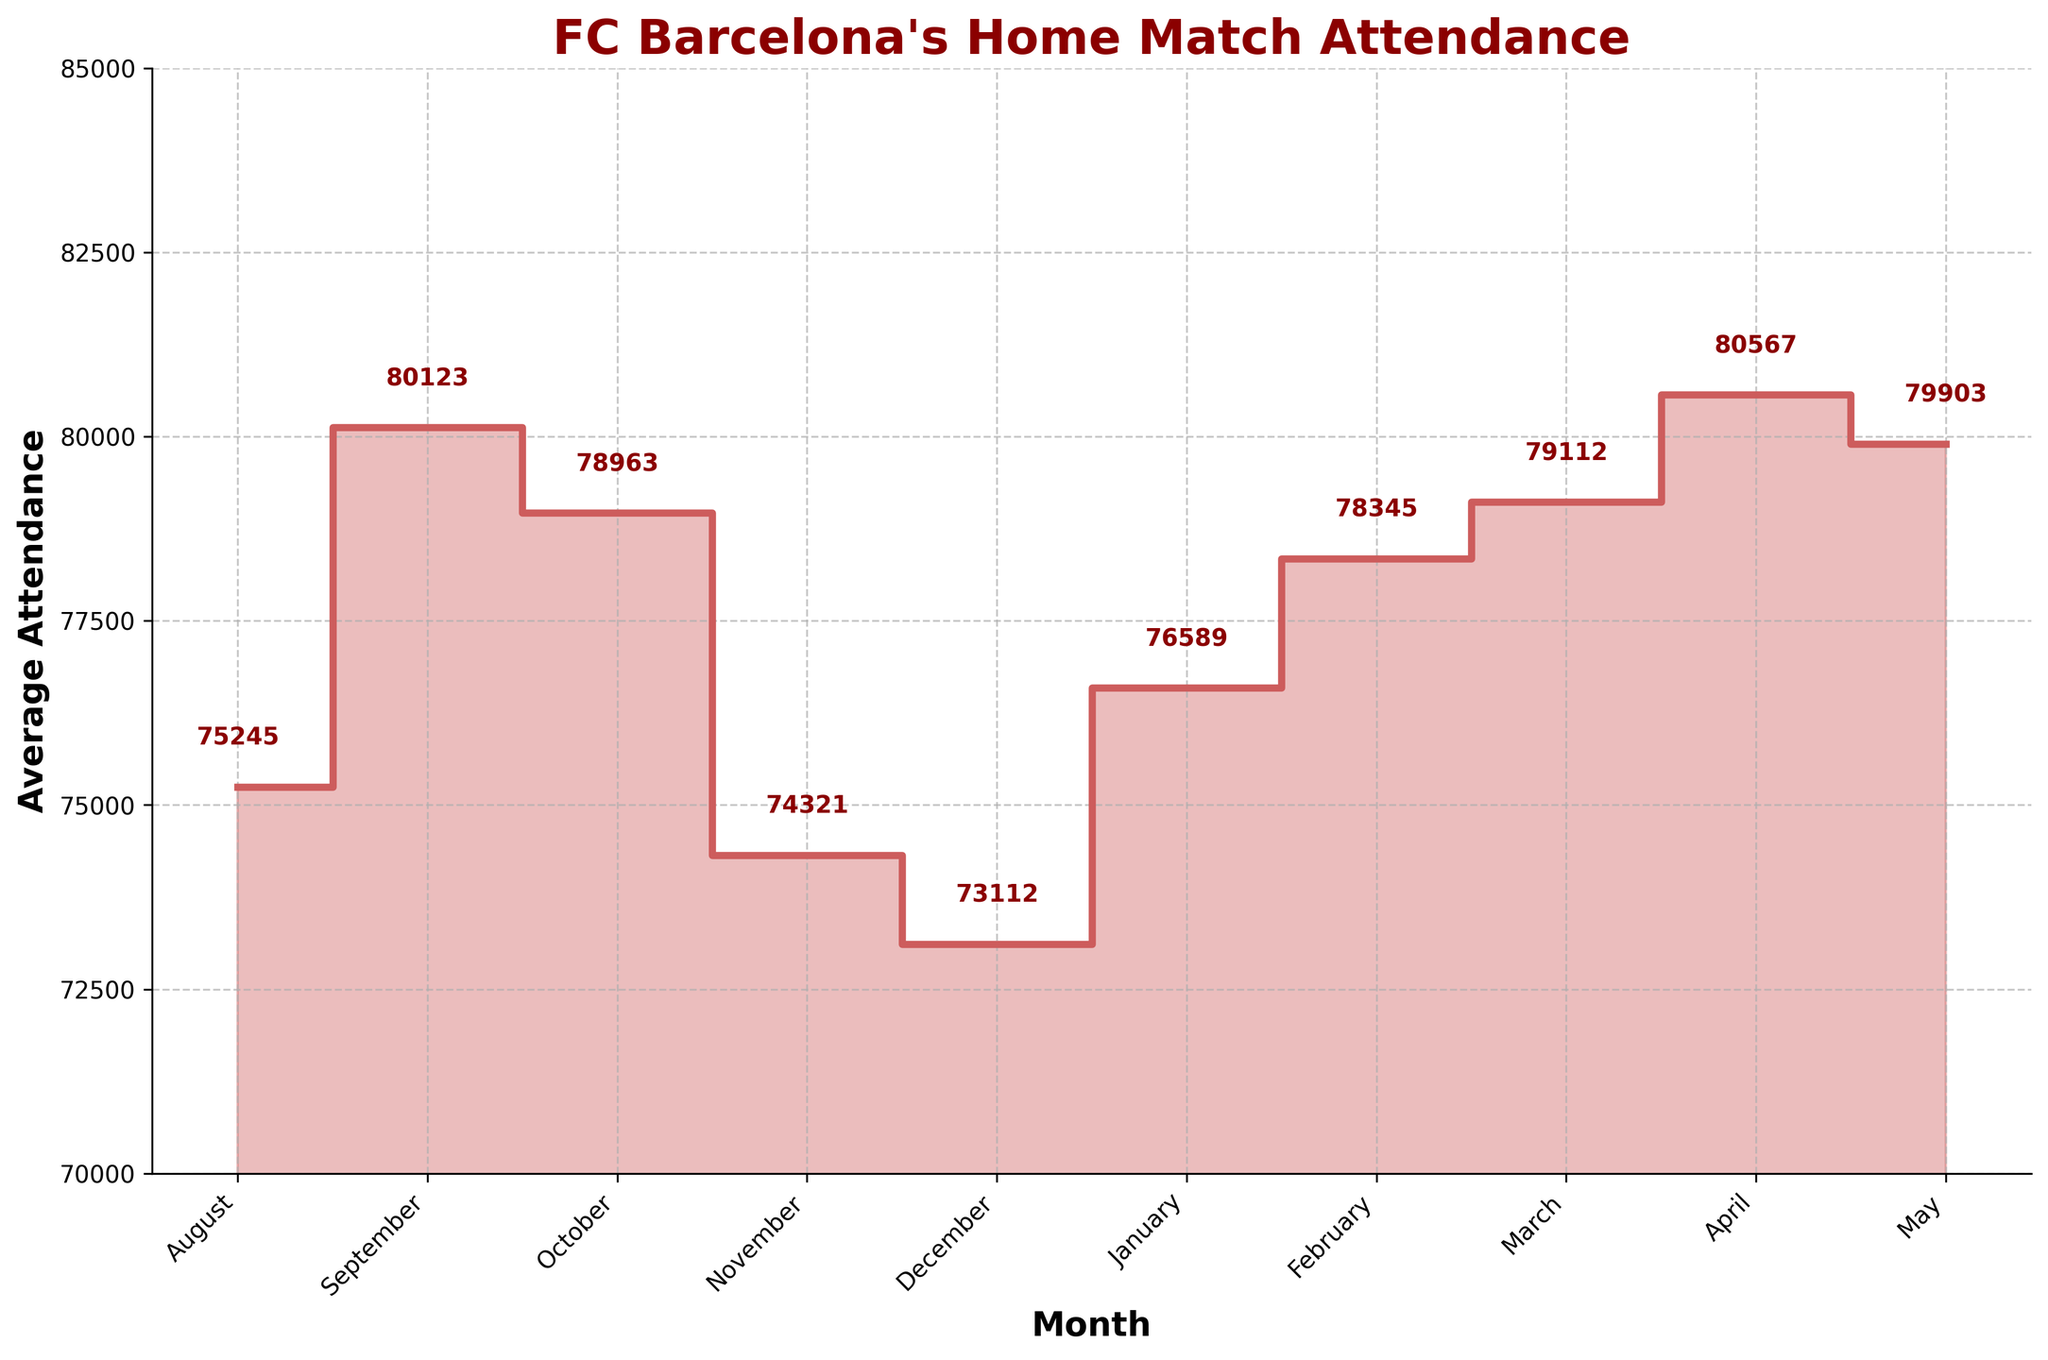What is the title of the chart? The title of a chart is always displayed at the top of the figure. In this chart, the title's text is bold and a dark red color.
Answer: FC Barcelona's Home Match Attendance What is the average attendance in January? To find this, locate the "January" label on the x-axis and then look at the corresponding y-axis value or the annotation on top of the January data point.
Answer: 76589 Which month had the highest average attendance? Look for the highest point on the vertical y-axis and find the corresponding month on the horizontal x-axis.
Answer: April How much did the average attendance change from August to September? First, find the average attendances for August (75245) and September (80123). Then, compute the difference between these two values.
Answer: 4878 Which months had an average attendance greater than 79,000? Check the y-axis values for each month and identify those exceeding 79,000.
Answer: September, March, April, May What is the average attendance for the last three months combined? Sum the average attendances for March (79112), April (80567), and May (79903), then divide by 3.
Answer: 79860.67 Which month saw the lowest average attendance and what was it? Identify the lowest point on the vertical y-axis and find the corresponding month on the horizontal x-axis.
Answer: December, 73112 How many months had an average attendance above the median value? First, find the median of the attendance values. Then, count how many months have values above this median.
Answer: 5 Comparing November and February, which month had a higher average attendance? By how much? First, find the average attendances for November (74321) and February (78345). Then, compute the difference between these two values.
Answer: February by 4024 What trend do you observe from December to January? Look at the values for December (73112) and January (76589) and note the direction (increase or decrease) between these two months.
Answer: Increase 